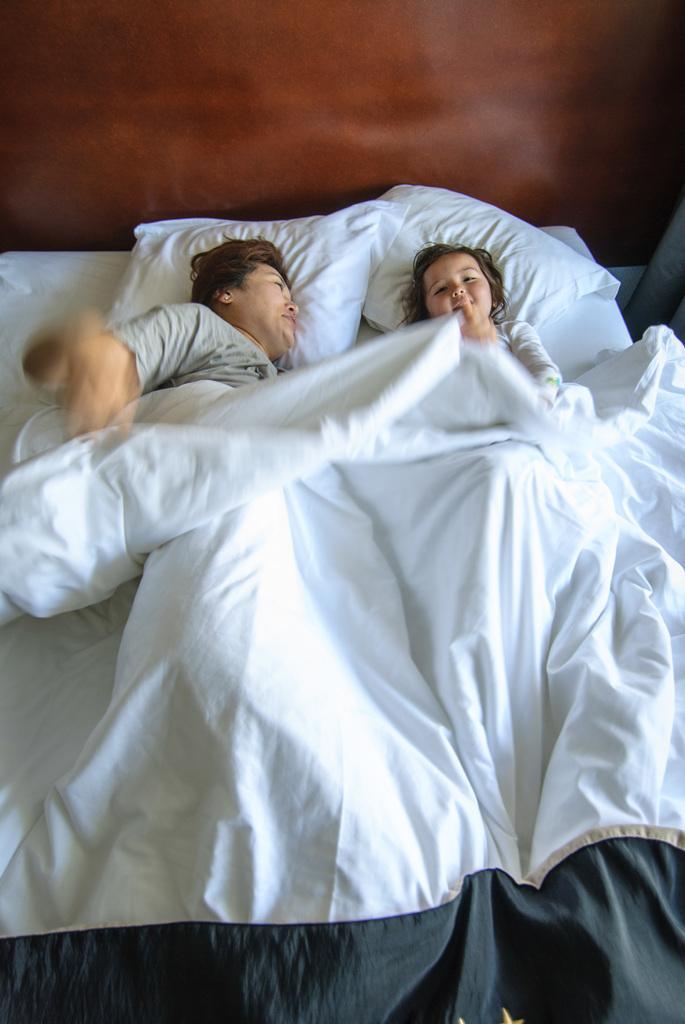In one or two sentences, can you explain what this image depicts? In this image I can see two people on the bed. 